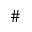Convert formula to latex. <formula><loc_0><loc_0><loc_500><loc_500>\#</formula> 